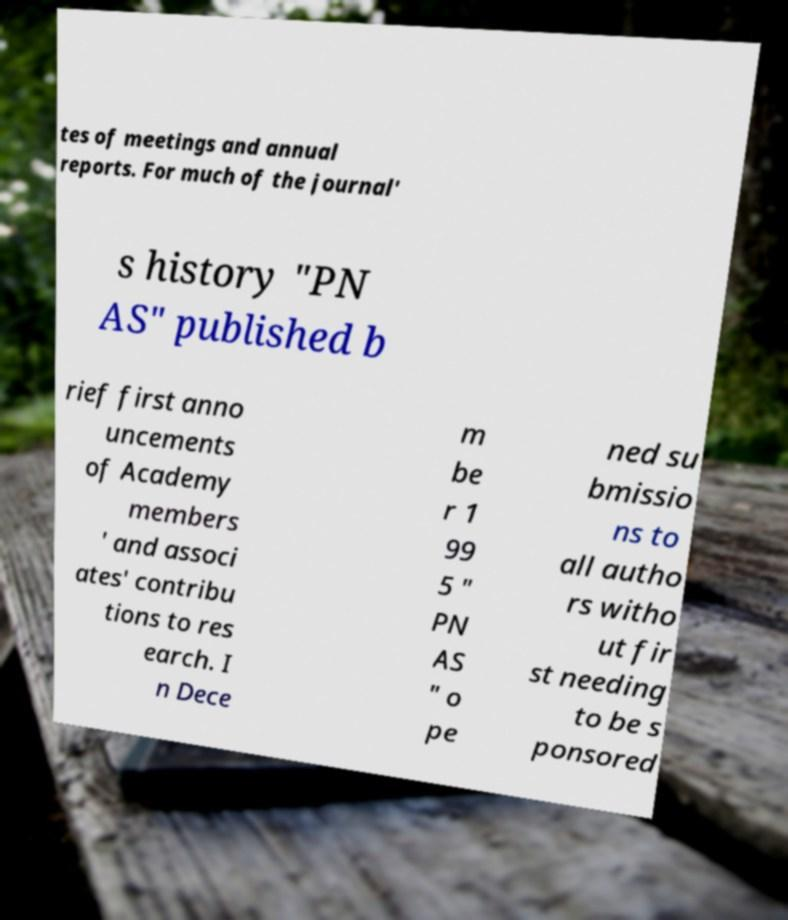For documentation purposes, I need the text within this image transcribed. Could you provide that? tes of meetings and annual reports. For much of the journal' s history "PN AS" published b rief first anno uncements of Academy members ' and associ ates' contribu tions to res earch. I n Dece m be r 1 99 5 " PN AS " o pe ned su bmissio ns to all autho rs witho ut fir st needing to be s ponsored 